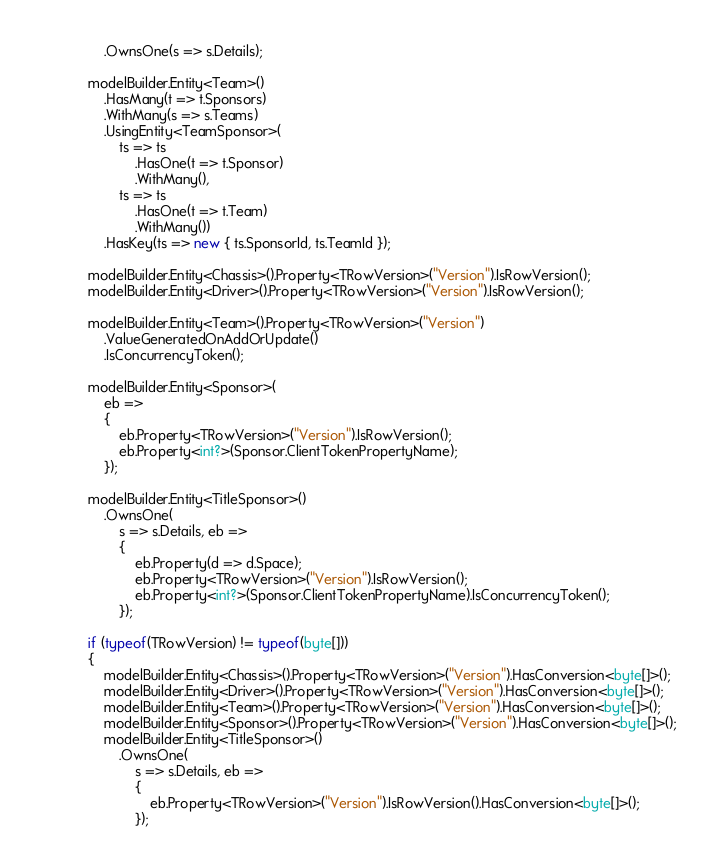<code> <loc_0><loc_0><loc_500><loc_500><_C#_>                .OwnsOne(s => s.Details);

            modelBuilder.Entity<Team>()
                .HasMany(t => t.Sponsors)
                .WithMany(s => s.Teams)
                .UsingEntity<TeamSponsor>(
                    ts => ts
                        .HasOne(t => t.Sponsor)
                        .WithMany(),
                    ts => ts
                        .HasOne(t => t.Team)
                        .WithMany())
                .HasKey(ts => new { ts.SponsorId, ts.TeamId });

            modelBuilder.Entity<Chassis>().Property<TRowVersion>("Version").IsRowVersion();
            modelBuilder.Entity<Driver>().Property<TRowVersion>("Version").IsRowVersion();

            modelBuilder.Entity<Team>().Property<TRowVersion>("Version")
                .ValueGeneratedOnAddOrUpdate()
                .IsConcurrencyToken();

            modelBuilder.Entity<Sponsor>(
                eb =>
                {
                    eb.Property<TRowVersion>("Version").IsRowVersion();
                    eb.Property<int?>(Sponsor.ClientTokenPropertyName);
                });

            modelBuilder.Entity<TitleSponsor>()
                .OwnsOne(
                    s => s.Details, eb =>
                    {
                        eb.Property(d => d.Space);
                        eb.Property<TRowVersion>("Version").IsRowVersion();
                        eb.Property<int?>(Sponsor.ClientTokenPropertyName).IsConcurrencyToken();
                    });

            if (typeof(TRowVersion) != typeof(byte[]))
            {
                modelBuilder.Entity<Chassis>().Property<TRowVersion>("Version").HasConversion<byte[]>();
                modelBuilder.Entity<Driver>().Property<TRowVersion>("Version").HasConversion<byte[]>();
                modelBuilder.Entity<Team>().Property<TRowVersion>("Version").HasConversion<byte[]>();
                modelBuilder.Entity<Sponsor>().Property<TRowVersion>("Version").HasConversion<byte[]>();
                modelBuilder.Entity<TitleSponsor>()
                    .OwnsOne(
                        s => s.Details, eb =>
                        {
                            eb.Property<TRowVersion>("Version").IsRowVersion().HasConversion<byte[]>();
                        });</code> 